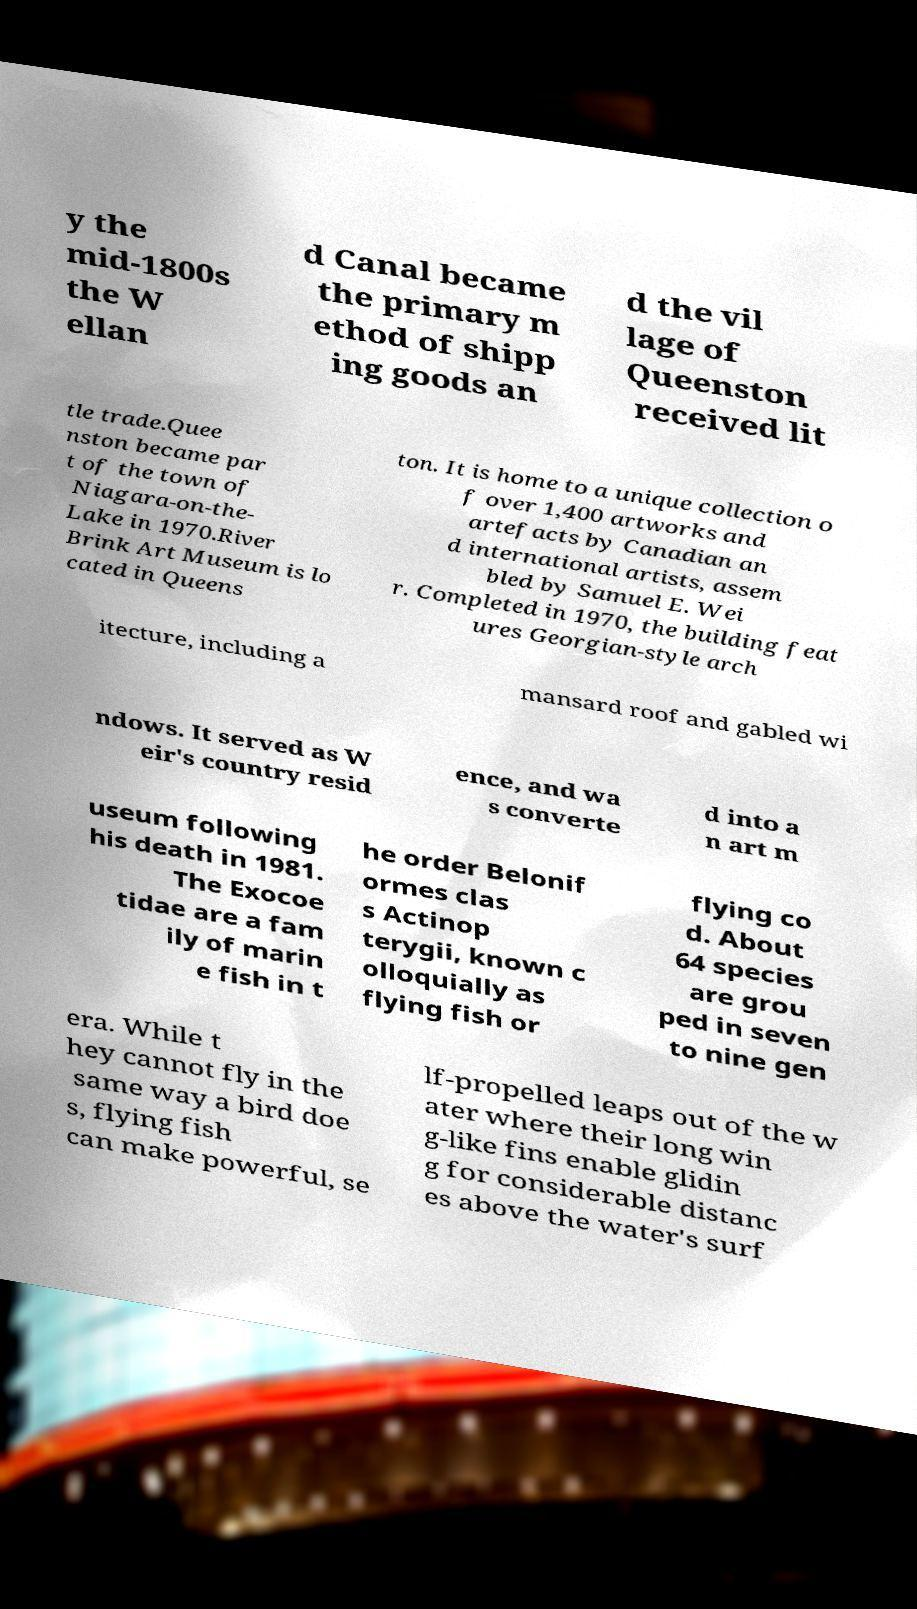For documentation purposes, I need the text within this image transcribed. Could you provide that? y the mid-1800s the W ellan d Canal became the primary m ethod of shipp ing goods an d the vil lage of Queenston received lit tle trade.Quee nston became par t of the town of Niagara-on-the- Lake in 1970.River Brink Art Museum is lo cated in Queens ton. It is home to a unique collection o f over 1,400 artworks and artefacts by Canadian an d international artists, assem bled by Samuel E. Wei r. Completed in 1970, the building feat ures Georgian-style arch itecture, including a mansard roof and gabled wi ndows. It served as W eir's country resid ence, and wa s converte d into a n art m useum following his death in 1981. The Exocoe tidae are a fam ily of marin e fish in t he order Belonif ormes clas s Actinop terygii, known c olloquially as flying fish or flying co d. About 64 species are grou ped in seven to nine gen era. While t hey cannot fly in the same way a bird doe s, flying fish can make powerful, se lf-propelled leaps out of the w ater where their long win g-like fins enable glidin g for considerable distanc es above the water's surf 